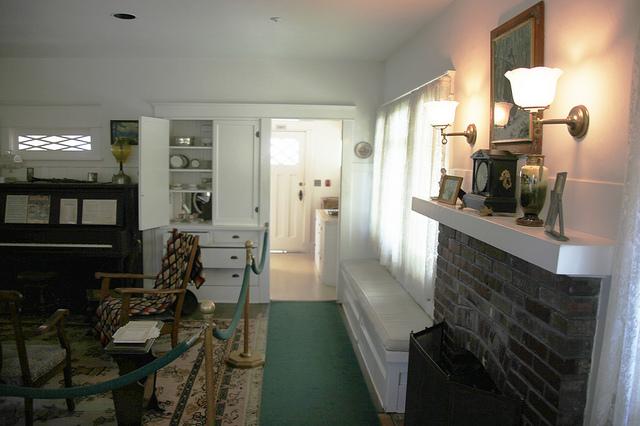What color are the rugs?
Concise answer only. Green. Why are there stanchions roping off part of this room?
Write a very short answer. Display. Is this a lobby?
Answer briefly. No. Is the back door open?
Give a very brief answer. No. What type of cord is shown?
Give a very brief answer. Velvet. What pattern is on the floor?
Keep it brief. Solid. 